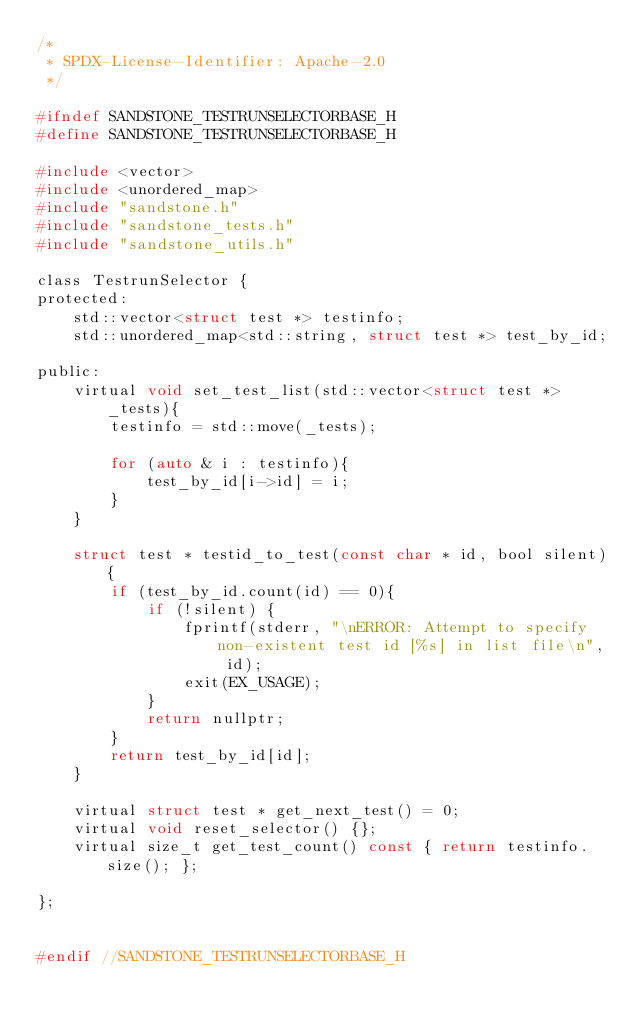<code> <loc_0><loc_0><loc_500><loc_500><_C_>/*
 * SPDX-License-Identifier: Apache-2.0
 */

#ifndef SANDSTONE_TESTRUNSELECTORBASE_H
#define SANDSTONE_TESTRUNSELECTORBASE_H

#include <vector>
#include <unordered_map>
#include "sandstone.h"
#include "sandstone_tests.h"
#include "sandstone_utils.h"

class TestrunSelector {
protected:
    std::vector<struct test *> testinfo;
    std::unordered_map<std::string, struct test *> test_by_id;

public:
    virtual void set_test_list(std::vector<struct test *> _tests){
        testinfo = std::move(_tests);

        for (auto & i : testinfo){
            test_by_id[i->id] = i;
        }
    }

    struct test * testid_to_test(const char * id, bool silent){
        if (test_by_id.count(id) == 0){
            if (!silent) {
                fprintf(stderr, "\nERROR: Attempt to specify non-existent test id [%s] in list file\n", id);
                exit(EX_USAGE);
            }
            return nullptr;
        }
        return test_by_id[id];
    }

    virtual struct test * get_next_test() = 0;
    virtual void reset_selector() {};
    virtual size_t get_test_count() const { return testinfo.size(); };

};


#endif //SANDSTONE_TESTRUNSELECTORBASE_H
</code> 